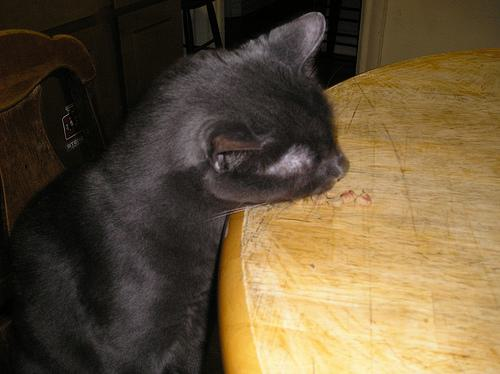What is the cat doing in the image? The cat appears to be intently sniffing or inspecting something small on the table, possibly a piece of food or an object that has caught its interest. Can you tell more about the cat's expression or body language? The cat's ears are slightly back and its eyes are focused, indicating curiosity or alertness towards whatever it has found on the table. 